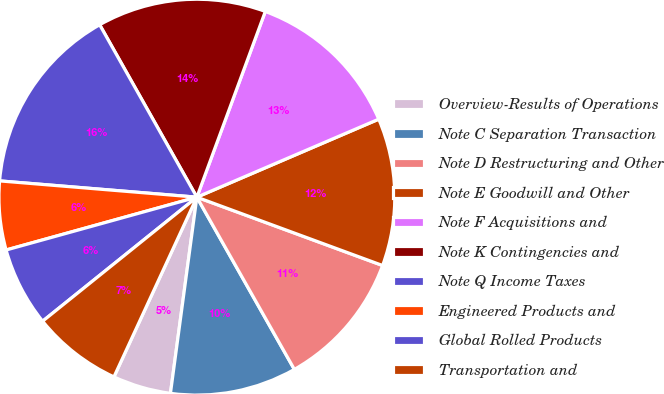Convert chart. <chart><loc_0><loc_0><loc_500><loc_500><pie_chart><fcel>Overview-Results of Operations<fcel>Note C Separation Transaction<fcel>Note D Restructuring and Other<fcel>Note E Goodwill and Other<fcel>Note F Acquisitions and<fcel>Note K Contingencies and<fcel>Note Q Income Taxes<fcel>Engineered Products and<fcel>Global Rolled Products<fcel>Transportation and<nl><fcel>4.75%<fcel>10.33%<fcel>11.19%<fcel>12.06%<fcel>12.93%<fcel>13.79%<fcel>15.52%<fcel>5.61%<fcel>6.48%<fcel>7.34%<nl></chart> 